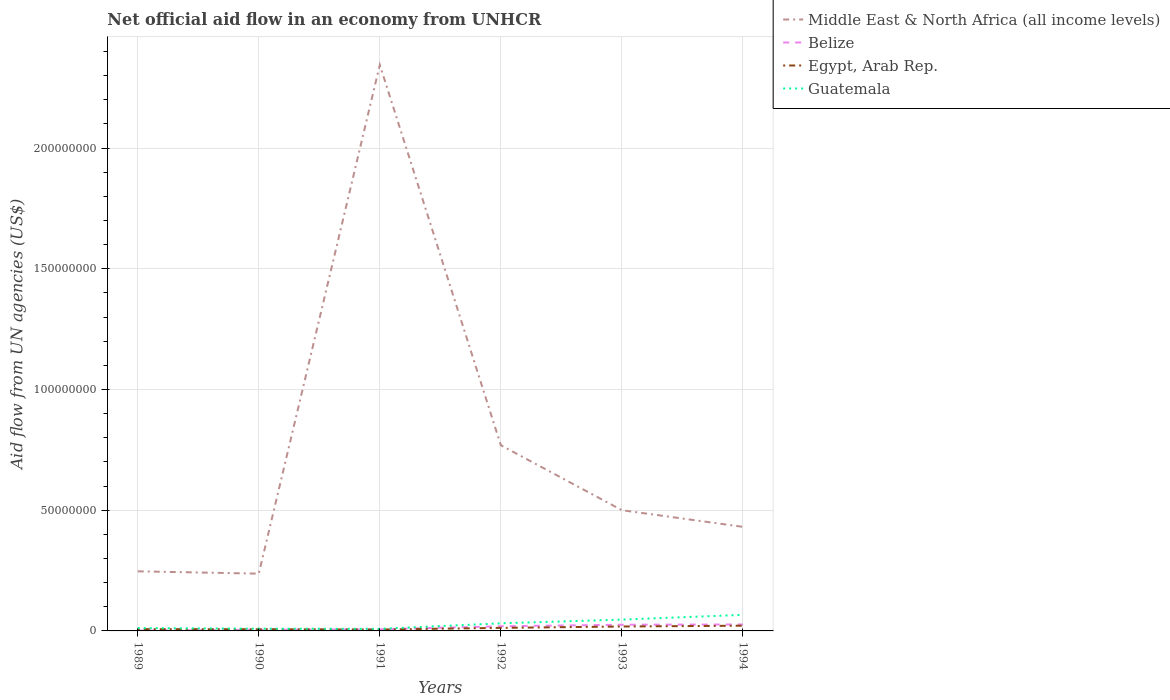What is the total net official aid flow in Middle East & North Africa (all income levels) in the graph?
Provide a succinct answer. -1.84e+07. What is the difference between the highest and the second highest net official aid flow in Middle East & North Africa (all income levels)?
Ensure brevity in your answer.  2.11e+08. What is the difference between the highest and the lowest net official aid flow in Belize?
Offer a terse response. 3. Is the net official aid flow in Middle East & North Africa (all income levels) strictly greater than the net official aid flow in Belize over the years?
Offer a terse response. No. How many years are there in the graph?
Give a very brief answer. 6. What is the difference between two consecutive major ticks on the Y-axis?
Your response must be concise. 5.00e+07. Are the values on the major ticks of Y-axis written in scientific E-notation?
Provide a short and direct response. No. Does the graph contain grids?
Your answer should be compact. Yes. Where does the legend appear in the graph?
Provide a succinct answer. Top right. How many legend labels are there?
Your response must be concise. 4. What is the title of the graph?
Your response must be concise. Net official aid flow in an economy from UNHCR. What is the label or title of the X-axis?
Offer a very short reply. Years. What is the label or title of the Y-axis?
Your answer should be compact. Aid flow from UN agencies (US$). What is the Aid flow from UN agencies (US$) of Middle East & North Africa (all income levels) in 1989?
Give a very brief answer. 2.47e+07. What is the Aid flow from UN agencies (US$) in Belize in 1989?
Ensure brevity in your answer.  1.50e+05. What is the Aid flow from UN agencies (US$) of Egypt, Arab Rep. in 1989?
Make the answer very short. 7.40e+05. What is the Aid flow from UN agencies (US$) of Guatemala in 1989?
Ensure brevity in your answer.  1.18e+06. What is the Aid flow from UN agencies (US$) of Middle East & North Africa (all income levels) in 1990?
Your response must be concise. 2.37e+07. What is the Aid flow from UN agencies (US$) of Belize in 1990?
Your answer should be very brief. 4.70e+05. What is the Aid flow from UN agencies (US$) of Egypt, Arab Rep. in 1990?
Ensure brevity in your answer.  7.00e+05. What is the Aid flow from UN agencies (US$) in Guatemala in 1990?
Keep it short and to the point. 9.20e+05. What is the Aid flow from UN agencies (US$) of Middle East & North Africa (all income levels) in 1991?
Your response must be concise. 2.34e+08. What is the Aid flow from UN agencies (US$) in Belize in 1991?
Offer a very short reply. 6.70e+05. What is the Aid flow from UN agencies (US$) of Egypt, Arab Rep. in 1991?
Keep it short and to the point. 5.70e+05. What is the Aid flow from UN agencies (US$) in Guatemala in 1991?
Offer a very short reply. 8.60e+05. What is the Aid flow from UN agencies (US$) in Middle East & North Africa (all income levels) in 1992?
Your answer should be very brief. 7.69e+07. What is the Aid flow from UN agencies (US$) of Belize in 1992?
Keep it short and to the point. 1.93e+06. What is the Aid flow from UN agencies (US$) of Egypt, Arab Rep. in 1992?
Give a very brief answer. 1.26e+06. What is the Aid flow from UN agencies (US$) of Guatemala in 1992?
Make the answer very short. 3.15e+06. What is the Aid flow from UN agencies (US$) in Middle East & North Africa (all income levels) in 1993?
Your response must be concise. 5.00e+07. What is the Aid flow from UN agencies (US$) in Belize in 1993?
Your answer should be very brief. 2.56e+06. What is the Aid flow from UN agencies (US$) in Egypt, Arab Rep. in 1993?
Your response must be concise. 1.83e+06. What is the Aid flow from UN agencies (US$) in Guatemala in 1993?
Provide a short and direct response. 4.69e+06. What is the Aid flow from UN agencies (US$) in Middle East & North Africa (all income levels) in 1994?
Your response must be concise. 4.31e+07. What is the Aid flow from UN agencies (US$) in Belize in 1994?
Your response must be concise. 2.67e+06. What is the Aid flow from UN agencies (US$) of Egypt, Arab Rep. in 1994?
Provide a short and direct response. 2.16e+06. What is the Aid flow from UN agencies (US$) of Guatemala in 1994?
Make the answer very short. 6.66e+06. Across all years, what is the maximum Aid flow from UN agencies (US$) of Middle East & North Africa (all income levels)?
Keep it short and to the point. 2.34e+08. Across all years, what is the maximum Aid flow from UN agencies (US$) of Belize?
Give a very brief answer. 2.67e+06. Across all years, what is the maximum Aid flow from UN agencies (US$) in Egypt, Arab Rep.?
Provide a succinct answer. 2.16e+06. Across all years, what is the maximum Aid flow from UN agencies (US$) in Guatemala?
Your answer should be compact. 6.66e+06. Across all years, what is the minimum Aid flow from UN agencies (US$) in Middle East & North Africa (all income levels)?
Provide a short and direct response. 2.37e+07. Across all years, what is the minimum Aid flow from UN agencies (US$) in Belize?
Make the answer very short. 1.50e+05. Across all years, what is the minimum Aid flow from UN agencies (US$) of Egypt, Arab Rep.?
Provide a short and direct response. 5.70e+05. Across all years, what is the minimum Aid flow from UN agencies (US$) in Guatemala?
Your response must be concise. 8.60e+05. What is the total Aid flow from UN agencies (US$) of Middle East & North Africa (all income levels) in the graph?
Provide a short and direct response. 4.53e+08. What is the total Aid flow from UN agencies (US$) in Belize in the graph?
Your answer should be very brief. 8.45e+06. What is the total Aid flow from UN agencies (US$) in Egypt, Arab Rep. in the graph?
Ensure brevity in your answer.  7.26e+06. What is the total Aid flow from UN agencies (US$) of Guatemala in the graph?
Keep it short and to the point. 1.75e+07. What is the difference between the Aid flow from UN agencies (US$) in Middle East & North Africa (all income levels) in 1989 and that in 1990?
Ensure brevity in your answer.  9.70e+05. What is the difference between the Aid flow from UN agencies (US$) in Belize in 1989 and that in 1990?
Give a very brief answer. -3.20e+05. What is the difference between the Aid flow from UN agencies (US$) of Guatemala in 1989 and that in 1990?
Ensure brevity in your answer.  2.60e+05. What is the difference between the Aid flow from UN agencies (US$) of Middle East & North Africa (all income levels) in 1989 and that in 1991?
Provide a short and direct response. -2.10e+08. What is the difference between the Aid flow from UN agencies (US$) in Belize in 1989 and that in 1991?
Your answer should be compact. -5.20e+05. What is the difference between the Aid flow from UN agencies (US$) of Guatemala in 1989 and that in 1991?
Provide a short and direct response. 3.20e+05. What is the difference between the Aid flow from UN agencies (US$) of Middle East & North Africa (all income levels) in 1989 and that in 1992?
Offer a very short reply. -5.22e+07. What is the difference between the Aid flow from UN agencies (US$) of Belize in 1989 and that in 1992?
Provide a short and direct response. -1.78e+06. What is the difference between the Aid flow from UN agencies (US$) of Egypt, Arab Rep. in 1989 and that in 1992?
Provide a succinct answer. -5.20e+05. What is the difference between the Aid flow from UN agencies (US$) of Guatemala in 1989 and that in 1992?
Your answer should be compact. -1.97e+06. What is the difference between the Aid flow from UN agencies (US$) of Middle East & North Africa (all income levels) in 1989 and that in 1993?
Offer a very short reply. -2.53e+07. What is the difference between the Aid flow from UN agencies (US$) of Belize in 1989 and that in 1993?
Provide a short and direct response. -2.41e+06. What is the difference between the Aid flow from UN agencies (US$) in Egypt, Arab Rep. in 1989 and that in 1993?
Offer a terse response. -1.09e+06. What is the difference between the Aid flow from UN agencies (US$) of Guatemala in 1989 and that in 1993?
Provide a short and direct response. -3.51e+06. What is the difference between the Aid flow from UN agencies (US$) of Middle East & North Africa (all income levels) in 1989 and that in 1994?
Make the answer very short. -1.84e+07. What is the difference between the Aid flow from UN agencies (US$) in Belize in 1989 and that in 1994?
Keep it short and to the point. -2.52e+06. What is the difference between the Aid flow from UN agencies (US$) in Egypt, Arab Rep. in 1989 and that in 1994?
Your answer should be very brief. -1.42e+06. What is the difference between the Aid flow from UN agencies (US$) of Guatemala in 1989 and that in 1994?
Make the answer very short. -5.48e+06. What is the difference between the Aid flow from UN agencies (US$) of Middle East & North Africa (all income levels) in 1990 and that in 1991?
Your answer should be compact. -2.11e+08. What is the difference between the Aid flow from UN agencies (US$) of Belize in 1990 and that in 1991?
Make the answer very short. -2.00e+05. What is the difference between the Aid flow from UN agencies (US$) in Egypt, Arab Rep. in 1990 and that in 1991?
Your answer should be very brief. 1.30e+05. What is the difference between the Aid flow from UN agencies (US$) in Middle East & North Africa (all income levels) in 1990 and that in 1992?
Provide a succinct answer. -5.32e+07. What is the difference between the Aid flow from UN agencies (US$) in Belize in 1990 and that in 1992?
Ensure brevity in your answer.  -1.46e+06. What is the difference between the Aid flow from UN agencies (US$) in Egypt, Arab Rep. in 1990 and that in 1992?
Your answer should be very brief. -5.60e+05. What is the difference between the Aid flow from UN agencies (US$) in Guatemala in 1990 and that in 1992?
Your response must be concise. -2.23e+06. What is the difference between the Aid flow from UN agencies (US$) of Middle East & North Africa (all income levels) in 1990 and that in 1993?
Provide a succinct answer. -2.63e+07. What is the difference between the Aid flow from UN agencies (US$) in Belize in 1990 and that in 1993?
Make the answer very short. -2.09e+06. What is the difference between the Aid flow from UN agencies (US$) in Egypt, Arab Rep. in 1990 and that in 1993?
Offer a very short reply. -1.13e+06. What is the difference between the Aid flow from UN agencies (US$) of Guatemala in 1990 and that in 1993?
Provide a succinct answer. -3.77e+06. What is the difference between the Aid flow from UN agencies (US$) in Middle East & North Africa (all income levels) in 1990 and that in 1994?
Keep it short and to the point. -1.94e+07. What is the difference between the Aid flow from UN agencies (US$) in Belize in 1990 and that in 1994?
Ensure brevity in your answer.  -2.20e+06. What is the difference between the Aid flow from UN agencies (US$) in Egypt, Arab Rep. in 1990 and that in 1994?
Offer a very short reply. -1.46e+06. What is the difference between the Aid flow from UN agencies (US$) in Guatemala in 1990 and that in 1994?
Keep it short and to the point. -5.74e+06. What is the difference between the Aid flow from UN agencies (US$) in Middle East & North Africa (all income levels) in 1991 and that in 1992?
Ensure brevity in your answer.  1.58e+08. What is the difference between the Aid flow from UN agencies (US$) in Belize in 1991 and that in 1992?
Ensure brevity in your answer.  -1.26e+06. What is the difference between the Aid flow from UN agencies (US$) in Egypt, Arab Rep. in 1991 and that in 1992?
Make the answer very short. -6.90e+05. What is the difference between the Aid flow from UN agencies (US$) in Guatemala in 1991 and that in 1992?
Provide a short and direct response. -2.29e+06. What is the difference between the Aid flow from UN agencies (US$) in Middle East & North Africa (all income levels) in 1991 and that in 1993?
Provide a short and direct response. 1.84e+08. What is the difference between the Aid flow from UN agencies (US$) in Belize in 1991 and that in 1993?
Make the answer very short. -1.89e+06. What is the difference between the Aid flow from UN agencies (US$) in Egypt, Arab Rep. in 1991 and that in 1993?
Your answer should be compact. -1.26e+06. What is the difference between the Aid flow from UN agencies (US$) in Guatemala in 1991 and that in 1993?
Provide a short and direct response. -3.83e+06. What is the difference between the Aid flow from UN agencies (US$) of Middle East & North Africa (all income levels) in 1991 and that in 1994?
Keep it short and to the point. 1.91e+08. What is the difference between the Aid flow from UN agencies (US$) in Egypt, Arab Rep. in 1991 and that in 1994?
Offer a very short reply. -1.59e+06. What is the difference between the Aid flow from UN agencies (US$) in Guatemala in 1991 and that in 1994?
Your answer should be very brief. -5.80e+06. What is the difference between the Aid flow from UN agencies (US$) of Middle East & North Africa (all income levels) in 1992 and that in 1993?
Your answer should be very brief. 2.69e+07. What is the difference between the Aid flow from UN agencies (US$) of Belize in 1992 and that in 1993?
Provide a short and direct response. -6.30e+05. What is the difference between the Aid flow from UN agencies (US$) in Egypt, Arab Rep. in 1992 and that in 1993?
Keep it short and to the point. -5.70e+05. What is the difference between the Aid flow from UN agencies (US$) in Guatemala in 1992 and that in 1993?
Make the answer very short. -1.54e+06. What is the difference between the Aid flow from UN agencies (US$) of Middle East & North Africa (all income levels) in 1992 and that in 1994?
Offer a very short reply. 3.38e+07. What is the difference between the Aid flow from UN agencies (US$) in Belize in 1992 and that in 1994?
Offer a terse response. -7.40e+05. What is the difference between the Aid flow from UN agencies (US$) in Egypt, Arab Rep. in 1992 and that in 1994?
Your answer should be compact. -9.00e+05. What is the difference between the Aid flow from UN agencies (US$) of Guatemala in 1992 and that in 1994?
Provide a succinct answer. -3.51e+06. What is the difference between the Aid flow from UN agencies (US$) in Middle East & North Africa (all income levels) in 1993 and that in 1994?
Offer a terse response. 6.89e+06. What is the difference between the Aid flow from UN agencies (US$) of Belize in 1993 and that in 1994?
Provide a succinct answer. -1.10e+05. What is the difference between the Aid flow from UN agencies (US$) in Egypt, Arab Rep. in 1993 and that in 1994?
Your answer should be very brief. -3.30e+05. What is the difference between the Aid flow from UN agencies (US$) of Guatemala in 1993 and that in 1994?
Offer a terse response. -1.97e+06. What is the difference between the Aid flow from UN agencies (US$) of Middle East & North Africa (all income levels) in 1989 and the Aid flow from UN agencies (US$) of Belize in 1990?
Provide a succinct answer. 2.42e+07. What is the difference between the Aid flow from UN agencies (US$) of Middle East & North Africa (all income levels) in 1989 and the Aid flow from UN agencies (US$) of Egypt, Arab Rep. in 1990?
Offer a terse response. 2.40e+07. What is the difference between the Aid flow from UN agencies (US$) in Middle East & North Africa (all income levels) in 1989 and the Aid flow from UN agencies (US$) in Guatemala in 1990?
Your response must be concise. 2.38e+07. What is the difference between the Aid flow from UN agencies (US$) of Belize in 1989 and the Aid flow from UN agencies (US$) of Egypt, Arab Rep. in 1990?
Give a very brief answer. -5.50e+05. What is the difference between the Aid flow from UN agencies (US$) in Belize in 1989 and the Aid flow from UN agencies (US$) in Guatemala in 1990?
Give a very brief answer. -7.70e+05. What is the difference between the Aid flow from UN agencies (US$) in Egypt, Arab Rep. in 1989 and the Aid flow from UN agencies (US$) in Guatemala in 1990?
Offer a terse response. -1.80e+05. What is the difference between the Aid flow from UN agencies (US$) of Middle East & North Africa (all income levels) in 1989 and the Aid flow from UN agencies (US$) of Belize in 1991?
Your answer should be very brief. 2.40e+07. What is the difference between the Aid flow from UN agencies (US$) of Middle East & North Africa (all income levels) in 1989 and the Aid flow from UN agencies (US$) of Egypt, Arab Rep. in 1991?
Keep it short and to the point. 2.41e+07. What is the difference between the Aid flow from UN agencies (US$) of Middle East & North Africa (all income levels) in 1989 and the Aid flow from UN agencies (US$) of Guatemala in 1991?
Keep it short and to the point. 2.38e+07. What is the difference between the Aid flow from UN agencies (US$) in Belize in 1989 and the Aid flow from UN agencies (US$) in Egypt, Arab Rep. in 1991?
Provide a succinct answer. -4.20e+05. What is the difference between the Aid flow from UN agencies (US$) in Belize in 1989 and the Aid flow from UN agencies (US$) in Guatemala in 1991?
Keep it short and to the point. -7.10e+05. What is the difference between the Aid flow from UN agencies (US$) in Egypt, Arab Rep. in 1989 and the Aid flow from UN agencies (US$) in Guatemala in 1991?
Offer a terse response. -1.20e+05. What is the difference between the Aid flow from UN agencies (US$) of Middle East & North Africa (all income levels) in 1989 and the Aid flow from UN agencies (US$) of Belize in 1992?
Provide a succinct answer. 2.28e+07. What is the difference between the Aid flow from UN agencies (US$) in Middle East & North Africa (all income levels) in 1989 and the Aid flow from UN agencies (US$) in Egypt, Arab Rep. in 1992?
Make the answer very short. 2.34e+07. What is the difference between the Aid flow from UN agencies (US$) of Middle East & North Africa (all income levels) in 1989 and the Aid flow from UN agencies (US$) of Guatemala in 1992?
Your response must be concise. 2.15e+07. What is the difference between the Aid flow from UN agencies (US$) of Belize in 1989 and the Aid flow from UN agencies (US$) of Egypt, Arab Rep. in 1992?
Your answer should be very brief. -1.11e+06. What is the difference between the Aid flow from UN agencies (US$) of Belize in 1989 and the Aid flow from UN agencies (US$) of Guatemala in 1992?
Make the answer very short. -3.00e+06. What is the difference between the Aid flow from UN agencies (US$) of Egypt, Arab Rep. in 1989 and the Aid flow from UN agencies (US$) of Guatemala in 1992?
Your answer should be very brief. -2.41e+06. What is the difference between the Aid flow from UN agencies (US$) in Middle East & North Africa (all income levels) in 1989 and the Aid flow from UN agencies (US$) in Belize in 1993?
Your answer should be very brief. 2.21e+07. What is the difference between the Aid flow from UN agencies (US$) in Middle East & North Africa (all income levels) in 1989 and the Aid flow from UN agencies (US$) in Egypt, Arab Rep. in 1993?
Your response must be concise. 2.29e+07. What is the difference between the Aid flow from UN agencies (US$) in Belize in 1989 and the Aid flow from UN agencies (US$) in Egypt, Arab Rep. in 1993?
Provide a succinct answer. -1.68e+06. What is the difference between the Aid flow from UN agencies (US$) in Belize in 1989 and the Aid flow from UN agencies (US$) in Guatemala in 1993?
Your response must be concise. -4.54e+06. What is the difference between the Aid flow from UN agencies (US$) in Egypt, Arab Rep. in 1989 and the Aid flow from UN agencies (US$) in Guatemala in 1993?
Make the answer very short. -3.95e+06. What is the difference between the Aid flow from UN agencies (US$) of Middle East & North Africa (all income levels) in 1989 and the Aid flow from UN agencies (US$) of Belize in 1994?
Offer a very short reply. 2.20e+07. What is the difference between the Aid flow from UN agencies (US$) in Middle East & North Africa (all income levels) in 1989 and the Aid flow from UN agencies (US$) in Egypt, Arab Rep. in 1994?
Give a very brief answer. 2.25e+07. What is the difference between the Aid flow from UN agencies (US$) in Middle East & North Africa (all income levels) in 1989 and the Aid flow from UN agencies (US$) in Guatemala in 1994?
Provide a short and direct response. 1.80e+07. What is the difference between the Aid flow from UN agencies (US$) of Belize in 1989 and the Aid flow from UN agencies (US$) of Egypt, Arab Rep. in 1994?
Provide a short and direct response. -2.01e+06. What is the difference between the Aid flow from UN agencies (US$) of Belize in 1989 and the Aid flow from UN agencies (US$) of Guatemala in 1994?
Your answer should be compact. -6.51e+06. What is the difference between the Aid flow from UN agencies (US$) in Egypt, Arab Rep. in 1989 and the Aid flow from UN agencies (US$) in Guatemala in 1994?
Make the answer very short. -5.92e+06. What is the difference between the Aid flow from UN agencies (US$) of Middle East & North Africa (all income levels) in 1990 and the Aid flow from UN agencies (US$) of Belize in 1991?
Offer a very short reply. 2.30e+07. What is the difference between the Aid flow from UN agencies (US$) of Middle East & North Africa (all income levels) in 1990 and the Aid flow from UN agencies (US$) of Egypt, Arab Rep. in 1991?
Your response must be concise. 2.32e+07. What is the difference between the Aid flow from UN agencies (US$) in Middle East & North Africa (all income levels) in 1990 and the Aid flow from UN agencies (US$) in Guatemala in 1991?
Provide a short and direct response. 2.29e+07. What is the difference between the Aid flow from UN agencies (US$) in Belize in 1990 and the Aid flow from UN agencies (US$) in Guatemala in 1991?
Offer a terse response. -3.90e+05. What is the difference between the Aid flow from UN agencies (US$) of Egypt, Arab Rep. in 1990 and the Aid flow from UN agencies (US$) of Guatemala in 1991?
Offer a very short reply. -1.60e+05. What is the difference between the Aid flow from UN agencies (US$) in Middle East & North Africa (all income levels) in 1990 and the Aid flow from UN agencies (US$) in Belize in 1992?
Offer a very short reply. 2.18e+07. What is the difference between the Aid flow from UN agencies (US$) in Middle East & North Africa (all income levels) in 1990 and the Aid flow from UN agencies (US$) in Egypt, Arab Rep. in 1992?
Provide a short and direct response. 2.25e+07. What is the difference between the Aid flow from UN agencies (US$) of Middle East & North Africa (all income levels) in 1990 and the Aid flow from UN agencies (US$) of Guatemala in 1992?
Offer a very short reply. 2.06e+07. What is the difference between the Aid flow from UN agencies (US$) of Belize in 1990 and the Aid flow from UN agencies (US$) of Egypt, Arab Rep. in 1992?
Your answer should be compact. -7.90e+05. What is the difference between the Aid flow from UN agencies (US$) in Belize in 1990 and the Aid flow from UN agencies (US$) in Guatemala in 1992?
Your answer should be compact. -2.68e+06. What is the difference between the Aid flow from UN agencies (US$) of Egypt, Arab Rep. in 1990 and the Aid flow from UN agencies (US$) of Guatemala in 1992?
Your response must be concise. -2.45e+06. What is the difference between the Aid flow from UN agencies (US$) in Middle East & North Africa (all income levels) in 1990 and the Aid flow from UN agencies (US$) in Belize in 1993?
Your answer should be very brief. 2.12e+07. What is the difference between the Aid flow from UN agencies (US$) of Middle East & North Africa (all income levels) in 1990 and the Aid flow from UN agencies (US$) of Egypt, Arab Rep. in 1993?
Give a very brief answer. 2.19e+07. What is the difference between the Aid flow from UN agencies (US$) of Middle East & North Africa (all income levels) in 1990 and the Aid flow from UN agencies (US$) of Guatemala in 1993?
Provide a succinct answer. 1.90e+07. What is the difference between the Aid flow from UN agencies (US$) in Belize in 1990 and the Aid flow from UN agencies (US$) in Egypt, Arab Rep. in 1993?
Give a very brief answer. -1.36e+06. What is the difference between the Aid flow from UN agencies (US$) in Belize in 1990 and the Aid flow from UN agencies (US$) in Guatemala in 1993?
Give a very brief answer. -4.22e+06. What is the difference between the Aid flow from UN agencies (US$) in Egypt, Arab Rep. in 1990 and the Aid flow from UN agencies (US$) in Guatemala in 1993?
Offer a very short reply. -3.99e+06. What is the difference between the Aid flow from UN agencies (US$) in Middle East & North Africa (all income levels) in 1990 and the Aid flow from UN agencies (US$) in Belize in 1994?
Offer a very short reply. 2.10e+07. What is the difference between the Aid flow from UN agencies (US$) in Middle East & North Africa (all income levels) in 1990 and the Aid flow from UN agencies (US$) in Egypt, Arab Rep. in 1994?
Keep it short and to the point. 2.16e+07. What is the difference between the Aid flow from UN agencies (US$) in Middle East & North Africa (all income levels) in 1990 and the Aid flow from UN agencies (US$) in Guatemala in 1994?
Your answer should be compact. 1.71e+07. What is the difference between the Aid flow from UN agencies (US$) in Belize in 1990 and the Aid flow from UN agencies (US$) in Egypt, Arab Rep. in 1994?
Make the answer very short. -1.69e+06. What is the difference between the Aid flow from UN agencies (US$) of Belize in 1990 and the Aid flow from UN agencies (US$) of Guatemala in 1994?
Provide a succinct answer. -6.19e+06. What is the difference between the Aid flow from UN agencies (US$) of Egypt, Arab Rep. in 1990 and the Aid flow from UN agencies (US$) of Guatemala in 1994?
Your answer should be compact. -5.96e+06. What is the difference between the Aid flow from UN agencies (US$) in Middle East & North Africa (all income levels) in 1991 and the Aid flow from UN agencies (US$) in Belize in 1992?
Provide a succinct answer. 2.33e+08. What is the difference between the Aid flow from UN agencies (US$) in Middle East & North Africa (all income levels) in 1991 and the Aid flow from UN agencies (US$) in Egypt, Arab Rep. in 1992?
Give a very brief answer. 2.33e+08. What is the difference between the Aid flow from UN agencies (US$) in Middle East & North Africa (all income levels) in 1991 and the Aid flow from UN agencies (US$) in Guatemala in 1992?
Give a very brief answer. 2.31e+08. What is the difference between the Aid flow from UN agencies (US$) in Belize in 1991 and the Aid flow from UN agencies (US$) in Egypt, Arab Rep. in 1992?
Provide a short and direct response. -5.90e+05. What is the difference between the Aid flow from UN agencies (US$) of Belize in 1991 and the Aid flow from UN agencies (US$) of Guatemala in 1992?
Your answer should be compact. -2.48e+06. What is the difference between the Aid flow from UN agencies (US$) in Egypt, Arab Rep. in 1991 and the Aid flow from UN agencies (US$) in Guatemala in 1992?
Your answer should be compact. -2.58e+06. What is the difference between the Aid flow from UN agencies (US$) of Middle East & North Africa (all income levels) in 1991 and the Aid flow from UN agencies (US$) of Belize in 1993?
Offer a terse response. 2.32e+08. What is the difference between the Aid flow from UN agencies (US$) in Middle East & North Africa (all income levels) in 1991 and the Aid flow from UN agencies (US$) in Egypt, Arab Rep. in 1993?
Keep it short and to the point. 2.33e+08. What is the difference between the Aid flow from UN agencies (US$) of Middle East & North Africa (all income levels) in 1991 and the Aid flow from UN agencies (US$) of Guatemala in 1993?
Give a very brief answer. 2.30e+08. What is the difference between the Aid flow from UN agencies (US$) of Belize in 1991 and the Aid flow from UN agencies (US$) of Egypt, Arab Rep. in 1993?
Offer a terse response. -1.16e+06. What is the difference between the Aid flow from UN agencies (US$) in Belize in 1991 and the Aid flow from UN agencies (US$) in Guatemala in 1993?
Give a very brief answer. -4.02e+06. What is the difference between the Aid flow from UN agencies (US$) of Egypt, Arab Rep. in 1991 and the Aid flow from UN agencies (US$) of Guatemala in 1993?
Your answer should be compact. -4.12e+06. What is the difference between the Aid flow from UN agencies (US$) in Middle East & North Africa (all income levels) in 1991 and the Aid flow from UN agencies (US$) in Belize in 1994?
Your answer should be very brief. 2.32e+08. What is the difference between the Aid flow from UN agencies (US$) in Middle East & North Africa (all income levels) in 1991 and the Aid flow from UN agencies (US$) in Egypt, Arab Rep. in 1994?
Keep it short and to the point. 2.32e+08. What is the difference between the Aid flow from UN agencies (US$) of Middle East & North Africa (all income levels) in 1991 and the Aid flow from UN agencies (US$) of Guatemala in 1994?
Provide a succinct answer. 2.28e+08. What is the difference between the Aid flow from UN agencies (US$) in Belize in 1991 and the Aid flow from UN agencies (US$) in Egypt, Arab Rep. in 1994?
Your response must be concise. -1.49e+06. What is the difference between the Aid flow from UN agencies (US$) of Belize in 1991 and the Aid flow from UN agencies (US$) of Guatemala in 1994?
Ensure brevity in your answer.  -5.99e+06. What is the difference between the Aid flow from UN agencies (US$) of Egypt, Arab Rep. in 1991 and the Aid flow from UN agencies (US$) of Guatemala in 1994?
Provide a succinct answer. -6.09e+06. What is the difference between the Aid flow from UN agencies (US$) of Middle East & North Africa (all income levels) in 1992 and the Aid flow from UN agencies (US$) of Belize in 1993?
Provide a succinct answer. 7.44e+07. What is the difference between the Aid flow from UN agencies (US$) in Middle East & North Africa (all income levels) in 1992 and the Aid flow from UN agencies (US$) in Egypt, Arab Rep. in 1993?
Offer a terse response. 7.51e+07. What is the difference between the Aid flow from UN agencies (US$) of Middle East & North Africa (all income levels) in 1992 and the Aid flow from UN agencies (US$) of Guatemala in 1993?
Ensure brevity in your answer.  7.22e+07. What is the difference between the Aid flow from UN agencies (US$) in Belize in 1992 and the Aid flow from UN agencies (US$) in Egypt, Arab Rep. in 1993?
Your answer should be compact. 1.00e+05. What is the difference between the Aid flow from UN agencies (US$) of Belize in 1992 and the Aid flow from UN agencies (US$) of Guatemala in 1993?
Give a very brief answer. -2.76e+06. What is the difference between the Aid flow from UN agencies (US$) of Egypt, Arab Rep. in 1992 and the Aid flow from UN agencies (US$) of Guatemala in 1993?
Make the answer very short. -3.43e+06. What is the difference between the Aid flow from UN agencies (US$) of Middle East & North Africa (all income levels) in 1992 and the Aid flow from UN agencies (US$) of Belize in 1994?
Provide a succinct answer. 7.42e+07. What is the difference between the Aid flow from UN agencies (US$) in Middle East & North Africa (all income levels) in 1992 and the Aid flow from UN agencies (US$) in Egypt, Arab Rep. in 1994?
Offer a very short reply. 7.48e+07. What is the difference between the Aid flow from UN agencies (US$) of Middle East & North Africa (all income levels) in 1992 and the Aid flow from UN agencies (US$) of Guatemala in 1994?
Offer a very short reply. 7.02e+07. What is the difference between the Aid flow from UN agencies (US$) of Belize in 1992 and the Aid flow from UN agencies (US$) of Guatemala in 1994?
Give a very brief answer. -4.73e+06. What is the difference between the Aid flow from UN agencies (US$) of Egypt, Arab Rep. in 1992 and the Aid flow from UN agencies (US$) of Guatemala in 1994?
Keep it short and to the point. -5.40e+06. What is the difference between the Aid flow from UN agencies (US$) of Middle East & North Africa (all income levels) in 1993 and the Aid flow from UN agencies (US$) of Belize in 1994?
Your response must be concise. 4.73e+07. What is the difference between the Aid flow from UN agencies (US$) of Middle East & North Africa (all income levels) in 1993 and the Aid flow from UN agencies (US$) of Egypt, Arab Rep. in 1994?
Ensure brevity in your answer.  4.78e+07. What is the difference between the Aid flow from UN agencies (US$) of Middle East & North Africa (all income levels) in 1993 and the Aid flow from UN agencies (US$) of Guatemala in 1994?
Provide a short and direct response. 4.33e+07. What is the difference between the Aid flow from UN agencies (US$) in Belize in 1993 and the Aid flow from UN agencies (US$) in Guatemala in 1994?
Offer a very short reply. -4.10e+06. What is the difference between the Aid flow from UN agencies (US$) of Egypt, Arab Rep. in 1993 and the Aid flow from UN agencies (US$) of Guatemala in 1994?
Your answer should be compact. -4.83e+06. What is the average Aid flow from UN agencies (US$) of Middle East & North Africa (all income levels) per year?
Ensure brevity in your answer.  7.55e+07. What is the average Aid flow from UN agencies (US$) of Belize per year?
Your answer should be very brief. 1.41e+06. What is the average Aid flow from UN agencies (US$) of Egypt, Arab Rep. per year?
Ensure brevity in your answer.  1.21e+06. What is the average Aid flow from UN agencies (US$) of Guatemala per year?
Give a very brief answer. 2.91e+06. In the year 1989, what is the difference between the Aid flow from UN agencies (US$) in Middle East & North Africa (all income levels) and Aid flow from UN agencies (US$) in Belize?
Provide a short and direct response. 2.45e+07. In the year 1989, what is the difference between the Aid flow from UN agencies (US$) in Middle East & North Africa (all income levels) and Aid flow from UN agencies (US$) in Egypt, Arab Rep.?
Give a very brief answer. 2.40e+07. In the year 1989, what is the difference between the Aid flow from UN agencies (US$) of Middle East & North Africa (all income levels) and Aid flow from UN agencies (US$) of Guatemala?
Your response must be concise. 2.35e+07. In the year 1989, what is the difference between the Aid flow from UN agencies (US$) in Belize and Aid flow from UN agencies (US$) in Egypt, Arab Rep.?
Your answer should be compact. -5.90e+05. In the year 1989, what is the difference between the Aid flow from UN agencies (US$) in Belize and Aid flow from UN agencies (US$) in Guatemala?
Ensure brevity in your answer.  -1.03e+06. In the year 1989, what is the difference between the Aid flow from UN agencies (US$) of Egypt, Arab Rep. and Aid flow from UN agencies (US$) of Guatemala?
Offer a terse response. -4.40e+05. In the year 1990, what is the difference between the Aid flow from UN agencies (US$) of Middle East & North Africa (all income levels) and Aid flow from UN agencies (US$) of Belize?
Give a very brief answer. 2.32e+07. In the year 1990, what is the difference between the Aid flow from UN agencies (US$) of Middle East & North Africa (all income levels) and Aid flow from UN agencies (US$) of Egypt, Arab Rep.?
Provide a succinct answer. 2.30e+07. In the year 1990, what is the difference between the Aid flow from UN agencies (US$) of Middle East & North Africa (all income levels) and Aid flow from UN agencies (US$) of Guatemala?
Offer a terse response. 2.28e+07. In the year 1990, what is the difference between the Aid flow from UN agencies (US$) in Belize and Aid flow from UN agencies (US$) in Guatemala?
Keep it short and to the point. -4.50e+05. In the year 1990, what is the difference between the Aid flow from UN agencies (US$) in Egypt, Arab Rep. and Aid flow from UN agencies (US$) in Guatemala?
Ensure brevity in your answer.  -2.20e+05. In the year 1991, what is the difference between the Aid flow from UN agencies (US$) of Middle East & North Africa (all income levels) and Aid flow from UN agencies (US$) of Belize?
Your response must be concise. 2.34e+08. In the year 1991, what is the difference between the Aid flow from UN agencies (US$) of Middle East & North Africa (all income levels) and Aid flow from UN agencies (US$) of Egypt, Arab Rep.?
Your answer should be very brief. 2.34e+08. In the year 1991, what is the difference between the Aid flow from UN agencies (US$) of Middle East & North Africa (all income levels) and Aid flow from UN agencies (US$) of Guatemala?
Offer a terse response. 2.34e+08. In the year 1992, what is the difference between the Aid flow from UN agencies (US$) in Middle East & North Africa (all income levels) and Aid flow from UN agencies (US$) in Belize?
Keep it short and to the point. 7.50e+07. In the year 1992, what is the difference between the Aid flow from UN agencies (US$) in Middle East & North Africa (all income levels) and Aid flow from UN agencies (US$) in Egypt, Arab Rep.?
Your answer should be compact. 7.56e+07. In the year 1992, what is the difference between the Aid flow from UN agencies (US$) of Middle East & North Africa (all income levels) and Aid flow from UN agencies (US$) of Guatemala?
Ensure brevity in your answer.  7.38e+07. In the year 1992, what is the difference between the Aid flow from UN agencies (US$) of Belize and Aid flow from UN agencies (US$) of Egypt, Arab Rep.?
Provide a short and direct response. 6.70e+05. In the year 1992, what is the difference between the Aid flow from UN agencies (US$) in Belize and Aid flow from UN agencies (US$) in Guatemala?
Offer a very short reply. -1.22e+06. In the year 1992, what is the difference between the Aid flow from UN agencies (US$) in Egypt, Arab Rep. and Aid flow from UN agencies (US$) in Guatemala?
Provide a short and direct response. -1.89e+06. In the year 1993, what is the difference between the Aid flow from UN agencies (US$) of Middle East & North Africa (all income levels) and Aid flow from UN agencies (US$) of Belize?
Provide a succinct answer. 4.74e+07. In the year 1993, what is the difference between the Aid flow from UN agencies (US$) in Middle East & North Africa (all income levels) and Aid flow from UN agencies (US$) in Egypt, Arab Rep.?
Your response must be concise. 4.82e+07. In the year 1993, what is the difference between the Aid flow from UN agencies (US$) in Middle East & North Africa (all income levels) and Aid flow from UN agencies (US$) in Guatemala?
Your response must be concise. 4.53e+07. In the year 1993, what is the difference between the Aid flow from UN agencies (US$) in Belize and Aid flow from UN agencies (US$) in Egypt, Arab Rep.?
Offer a terse response. 7.30e+05. In the year 1993, what is the difference between the Aid flow from UN agencies (US$) in Belize and Aid flow from UN agencies (US$) in Guatemala?
Your answer should be very brief. -2.13e+06. In the year 1993, what is the difference between the Aid flow from UN agencies (US$) in Egypt, Arab Rep. and Aid flow from UN agencies (US$) in Guatemala?
Ensure brevity in your answer.  -2.86e+06. In the year 1994, what is the difference between the Aid flow from UN agencies (US$) in Middle East & North Africa (all income levels) and Aid flow from UN agencies (US$) in Belize?
Your response must be concise. 4.04e+07. In the year 1994, what is the difference between the Aid flow from UN agencies (US$) in Middle East & North Africa (all income levels) and Aid flow from UN agencies (US$) in Egypt, Arab Rep.?
Your answer should be compact. 4.10e+07. In the year 1994, what is the difference between the Aid flow from UN agencies (US$) of Middle East & North Africa (all income levels) and Aid flow from UN agencies (US$) of Guatemala?
Offer a very short reply. 3.64e+07. In the year 1994, what is the difference between the Aid flow from UN agencies (US$) in Belize and Aid flow from UN agencies (US$) in Egypt, Arab Rep.?
Your response must be concise. 5.10e+05. In the year 1994, what is the difference between the Aid flow from UN agencies (US$) of Belize and Aid flow from UN agencies (US$) of Guatemala?
Your answer should be compact. -3.99e+06. In the year 1994, what is the difference between the Aid flow from UN agencies (US$) in Egypt, Arab Rep. and Aid flow from UN agencies (US$) in Guatemala?
Make the answer very short. -4.50e+06. What is the ratio of the Aid flow from UN agencies (US$) in Middle East & North Africa (all income levels) in 1989 to that in 1990?
Provide a succinct answer. 1.04. What is the ratio of the Aid flow from UN agencies (US$) of Belize in 1989 to that in 1990?
Provide a short and direct response. 0.32. What is the ratio of the Aid flow from UN agencies (US$) in Egypt, Arab Rep. in 1989 to that in 1990?
Make the answer very short. 1.06. What is the ratio of the Aid flow from UN agencies (US$) of Guatemala in 1989 to that in 1990?
Offer a terse response. 1.28. What is the ratio of the Aid flow from UN agencies (US$) in Middle East & North Africa (all income levels) in 1989 to that in 1991?
Provide a succinct answer. 0.11. What is the ratio of the Aid flow from UN agencies (US$) in Belize in 1989 to that in 1991?
Make the answer very short. 0.22. What is the ratio of the Aid flow from UN agencies (US$) of Egypt, Arab Rep. in 1989 to that in 1991?
Provide a succinct answer. 1.3. What is the ratio of the Aid flow from UN agencies (US$) of Guatemala in 1989 to that in 1991?
Offer a terse response. 1.37. What is the ratio of the Aid flow from UN agencies (US$) in Middle East & North Africa (all income levels) in 1989 to that in 1992?
Offer a very short reply. 0.32. What is the ratio of the Aid flow from UN agencies (US$) of Belize in 1989 to that in 1992?
Your answer should be compact. 0.08. What is the ratio of the Aid flow from UN agencies (US$) of Egypt, Arab Rep. in 1989 to that in 1992?
Give a very brief answer. 0.59. What is the ratio of the Aid flow from UN agencies (US$) of Guatemala in 1989 to that in 1992?
Offer a very short reply. 0.37. What is the ratio of the Aid flow from UN agencies (US$) of Middle East & North Africa (all income levels) in 1989 to that in 1993?
Your response must be concise. 0.49. What is the ratio of the Aid flow from UN agencies (US$) in Belize in 1989 to that in 1993?
Your answer should be compact. 0.06. What is the ratio of the Aid flow from UN agencies (US$) in Egypt, Arab Rep. in 1989 to that in 1993?
Your response must be concise. 0.4. What is the ratio of the Aid flow from UN agencies (US$) of Guatemala in 1989 to that in 1993?
Ensure brevity in your answer.  0.25. What is the ratio of the Aid flow from UN agencies (US$) of Middle East & North Africa (all income levels) in 1989 to that in 1994?
Ensure brevity in your answer.  0.57. What is the ratio of the Aid flow from UN agencies (US$) in Belize in 1989 to that in 1994?
Keep it short and to the point. 0.06. What is the ratio of the Aid flow from UN agencies (US$) in Egypt, Arab Rep. in 1989 to that in 1994?
Your answer should be compact. 0.34. What is the ratio of the Aid flow from UN agencies (US$) of Guatemala in 1989 to that in 1994?
Keep it short and to the point. 0.18. What is the ratio of the Aid flow from UN agencies (US$) in Middle East & North Africa (all income levels) in 1990 to that in 1991?
Your response must be concise. 0.1. What is the ratio of the Aid flow from UN agencies (US$) of Belize in 1990 to that in 1991?
Offer a very short reply. 0.7. What is the ratio of the Aid flow from UN agencies (US$) of Egypt, Arab Rep. in 1990 to that in 1991?
Your answer should be very brief. 1.23. What is the ratio of the Aid flow from UN agencies (US$) in Guatemala in 1990 to that in 1991?
Your answer should be very brief. 1.07. What is the ratio of the Aid flow from UN agencies (US$) in Middle East & North Africa (all income levels) in 1990 to that in 1992?
Offer a terse response. 0.31. What is the ratio of the Aid flow from UN agencies (US$) in Belize in 1990 to that in 1992?
Your response must be concise. 0.24. What is the ratio of the Aid flow from UN agencies (US$) in Egypt, Arab Rep. in 1990 to that in 1992?
Your answer should be compact. 0.56. What is the ratio of the Aid flow from UN agencies (US$) of Guatemala in 1990 to that in 1992?
Provide a succinct answer. 0.29. What is the ratio of the Aid flow from UN agencies (US$) in Middle East & North Africa (all income levels) in 1990 to that in 1993?
Your answer should be very brief. 0.47. What is the ratio of the Aid flow from UN agencies (US$) of Belize in 1990 to that in 1993?
Your answer should be very brief. 0.18. What is the ratio of the Aid flow from UN agencies (US$) of Egypt, Arab Rep. in 1990 to that in 1993?
Make the answer very short. 0.38. What is the ratio of the Aid flow from UN agencies (US$) in Guatemala in 1990 to that in 1993?
Your answer should be compact. 0.2. What is the ratio of the Aid flow from UN agencies (US$) of Middle East & North Africa (all income levels) in 1990 to that in 1994?
Offer a very short reply. 0.55. What is the ratio of the Aid flow from UN agencies (US$) of Belize in 1990 to that in 1994?
Offer a terse response. 0.18. What is the ratio of the Aid flow from UN agencies (US$) in Egypt, Arab Rep. in 1990 to that in 1994?
Ensure brevity in your answer.  0.32. What is the ratio of the Aid flow from UN agencies (US$) in Guatemala in 1990 to that in 1994?
Keep it short and to the point. 0.14. What is the ratio of the Aid flow from UN agencies (US$) in Middle East & North Africa (all income levels) in 1991 to that in 1992?
Your answer should be compact. 3.05. What is the ratio of the Aid flow from UN agencies (US$) of Belize in 1991 to that in 1992?
Your answer should be very brief. 0.35. What is the ratio of the Aid flow from UN agencies (US$) of Egypt, Arab Rep. in 1991 to that in 1992?
Make the answer very short. 0.45. What is the ratio of the Aid flow from UN agencies (US$) of Guatemala in 1991 to that in 1992?
Give a very brief answer. 0.27. What is the ratio of the Aid flow from UN agencies (US$) in Middle East & North Africa (all income levels) in 1991 to that in 1993?
Offer a very short reply. 4.69. What is the ratio of the Aid flow from UN agencies (US$) of Belize in 1991 to that in 1993?
Ensure brevity in your answer.  0.26. What is the ratio of the Aid flow from UN agencies (US$) of Egypt, Arab Rep. in 1991 to that in 1993?
Keep it short and to the point. 0.31. What is the ratio of the Aid flow from UN agencies (US$) in Guatemala in 1991 to that in 1993?
Make the answer very short. 0.18. What is the ratio of the Aid flow from UN agencies (US$) of Middle East & North Africa (all income levels) in 1991 to that in 1994?
Your response must be concise. 5.44. What is the ratio of the Aid flow from UN agencies (US$) of Belize in 1991 to that in 1994?
Your answer should be compact. 0.25. What is the ratio of the Aid flow from UN agencies (US$) in Egypt, Arab Rep. in 1991 to that in 1994?
Make the answer very short. 0.26. What is the ratio of the Aid flow from UN agencies (US$) of Guatemala in 1991 to that in 1994?
Keep it short and to the point. 0.13. What is the ratio of the Aid flow from UN agencies (US$) in Middle East & North Africa (all income levels) in 1992 to that in 1993?
Offer a terse response. 1.54. What is the ratio of the Aid flow from UN agencies (US$) of Belize in 1992 to that in 1993?
Ensure brevity in your answer.  0.75. What is the ratio of the Aid flow from UN agencies (US$) in Egypt, Arab Rep. in 1992 to that in 1993?
Keep it short and to the point. 0.69. What is the ratio of the Aid flow from UN agencies (US$) of Guatemala in 1992 to that in 1993?
Your response must be concise. 0.67. What is the ratio of the Aid flow from UN agencies (US$) in Middle East & North Africa (all income levels) in 1992 to that in 1994?
Your response must be concise. 1.78. What is the ratio of the Aid flow from UN agencies (US$) in Belize in 1992 to that in 1994?
Your response must be concise. 0.72. What is the ratio of the Aid flow from UN agencies (US$) of Egypt, Arab Rep. in 1992 to that in 1994?
Ensure brevity in your answer.  0.58. What is the ratio of the Aid flow from UN agencies (US$) in Guatemala in 1992 to that in 1994?
Keep it short and to the point. 0.47. What is the ratio of the Aid flow from UN agencies (US$) of Middle East & North Africa (all income levels) in 1993 to that in 1994?
Offer a terse response. 1.16. What is the ratio of the Aid flow from UN agencies (US$) in Belize in 1993 to that in 1994?
Provide a short and direct response. 0.96. What is the ratio of the Aid flow from UN agencies (US$) of Egypt, Arab Rep. in 1993 to that in 1994?
Ensure brevity in your answer.  0.85. What is the ratio of the Aid flow from UN agencies (US$) in Guatemala in 1993 to that in 1994?
Keep it short and to the point. 0.7. What is the difference between the highest and the second highest Aid flow from UN agencies (US$) in Middle East & North Africa (all income levels)?
Your response must be concise. 1.58e+08. What is the difference between the highest and the second highest Aid flow from UN agencies (US$) of Belize?
Give a very brief answer. 1.10e+05. What is the difference between the highest and the second highest Aid flow from UN agencies (US$) of Egypt, Arab Rep.?
Make the answer very short. 3.30e+05. What is the difference between the highest and the second highest Aid flow from UN agencies (US$) of Guatemala?
Your response must be concise. 1.97e+06. What is the difference between the highest and the lowest Aid flow from UN agencies (US$) in Middle East & North Africa (all income levels)?
Offer a terse response. 2.11e+08. What is the difference between the highest and the lowest Aid flow from UN agencies (US$) in Belize?
Your answer should be compact. 2.52e+06. What is the difference between the highest and the lowest Aid flow from UN agencies (US$) in Egypt, Arab Rep.?
Your response must be concise. 1.59e+06. What is the difference between the highest and the lowest Aid flow from UN agencies (US$) in Guatemala?
Provide a short and direct response. 5.80e+06. 